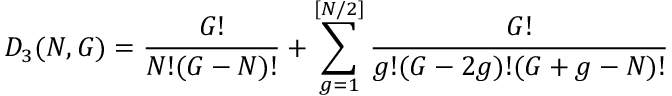Convert formula to latex. <formula><loc_0><loc_0><loc_500><loc_500>D _ { 3 } ( N , G ) = \frac { G ! } { N ! ( G - N ) ! } + \sum _ { g = 1 } ^ { [ N / 2 ] } \frac { G ! } { g ! ( G - 2 g ) ! ( G + g - N ) ! }</formula> 